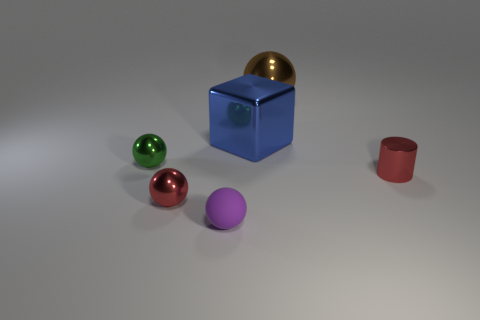Is there any other thing that is made of the same material as the tiny purple sphere?
Make the answer very short. No. What number of other things are there of the same color as the cylinder?
Provide a succinct answer. 1. There is a purple thing that is the same shape as the big brown thing; what is it made of?
Provide a short and direct response. Rubber. Is the number of large cyan matte blocks less than the number of cubes?
Offer a terse response. Yes. Is the red ball made of the same material as the big blue cube?
Ensure brevity in your answer.  Yes. What is the shape of the object that is the same color as the metallic cylinder?
Offer a very short reply. Sphere. There is a large shiny thing that is right of the block; is its color the same as the small rubber ball?
Your response must be concise. No. There is a red object to the left of the big metallic ball; what number of small red cylinders are in front of it?
Your response must be concise. 0. What is the color of the other metallic ball that is the same size as the red sphere?
Your response must be concise. Green. What is the material of the red object left of the purple object?
Provide a succinct answer. Metal. 